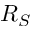<formula> <loc_0><loc_0><loc_500><loc_500>R _ { S }</formula> 